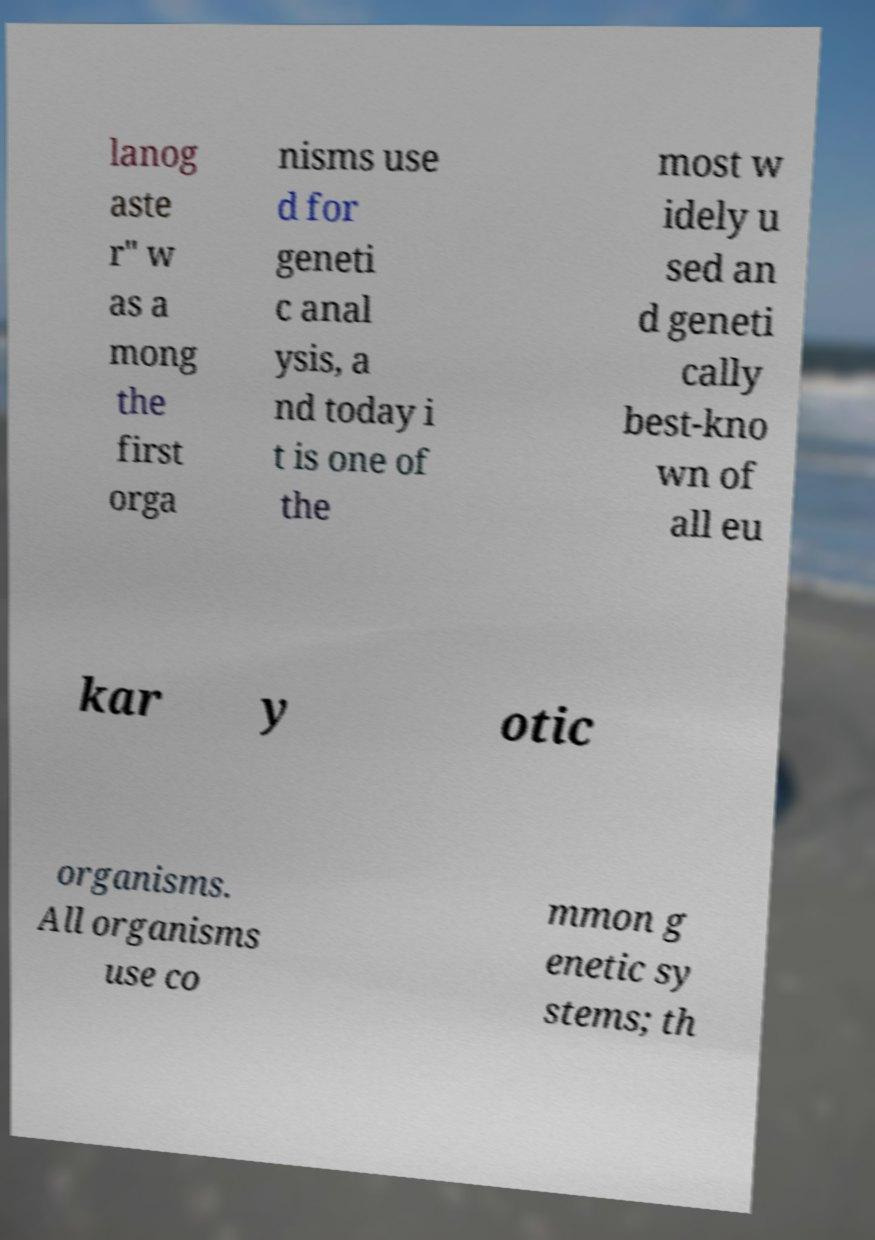Can you read and provide the text displayed in the image?This photo seems to have some interesting text. Can you extract and type it out for me? lanog aste r" w as a mong the first orga nisms use d for geneti c anal ysis, a nd today i t is one of the most w idely u sed an d geneti cally best-kno wn of all eu kar y otic organisms. All organisms use co mmon g enetic sy stems; th 